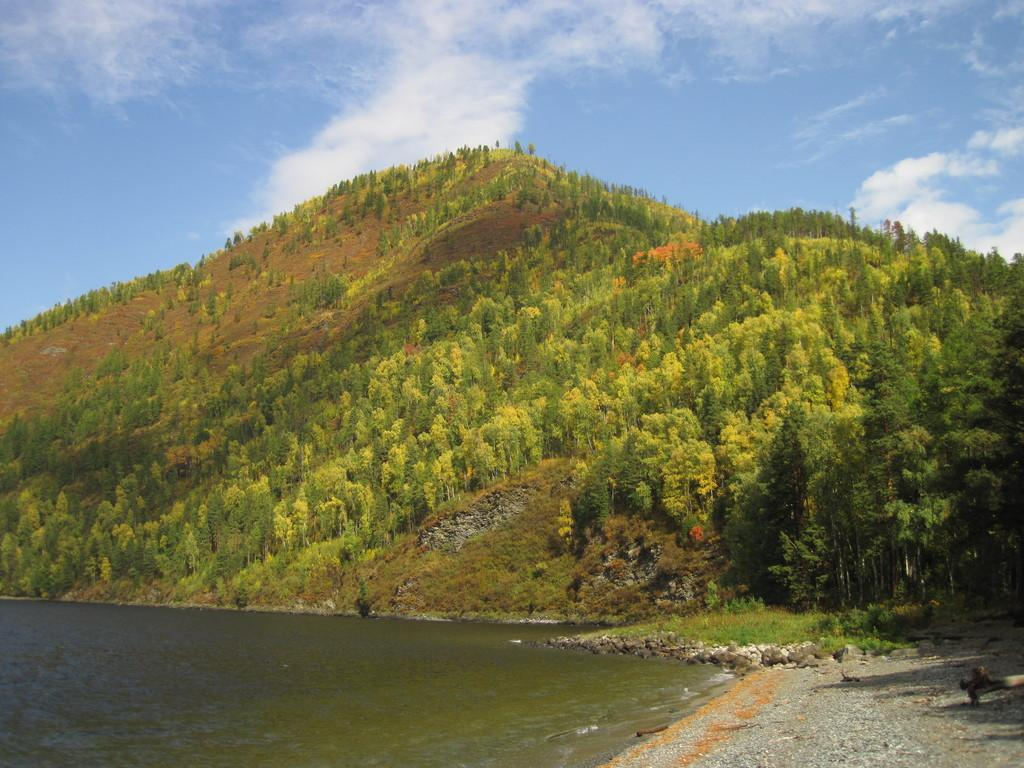What is the primary element visible in the image? There is water in the image. What type of surface is near the water? There is a stone surface near the water. What can be seen in the background of the image? There is grass, hills, and trees visible in the background. What is visible in the sky in the image? The sky is visible in the image, and clouds are present. How many legs can be seen on the stone surface in the image? There are no legs visible on the stone surface in the image. What type of dust is present on the grass in the image? There is no dust present on the grass in the image. 